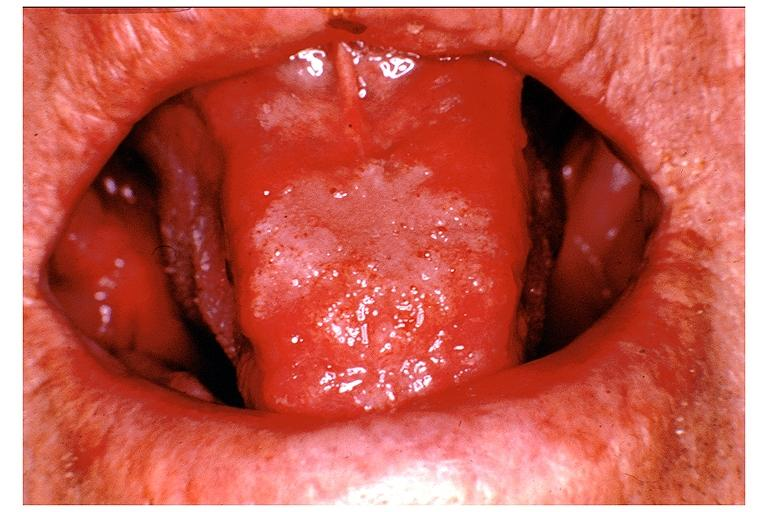what is present?
Answer the question using a single word or phrase. Oral 